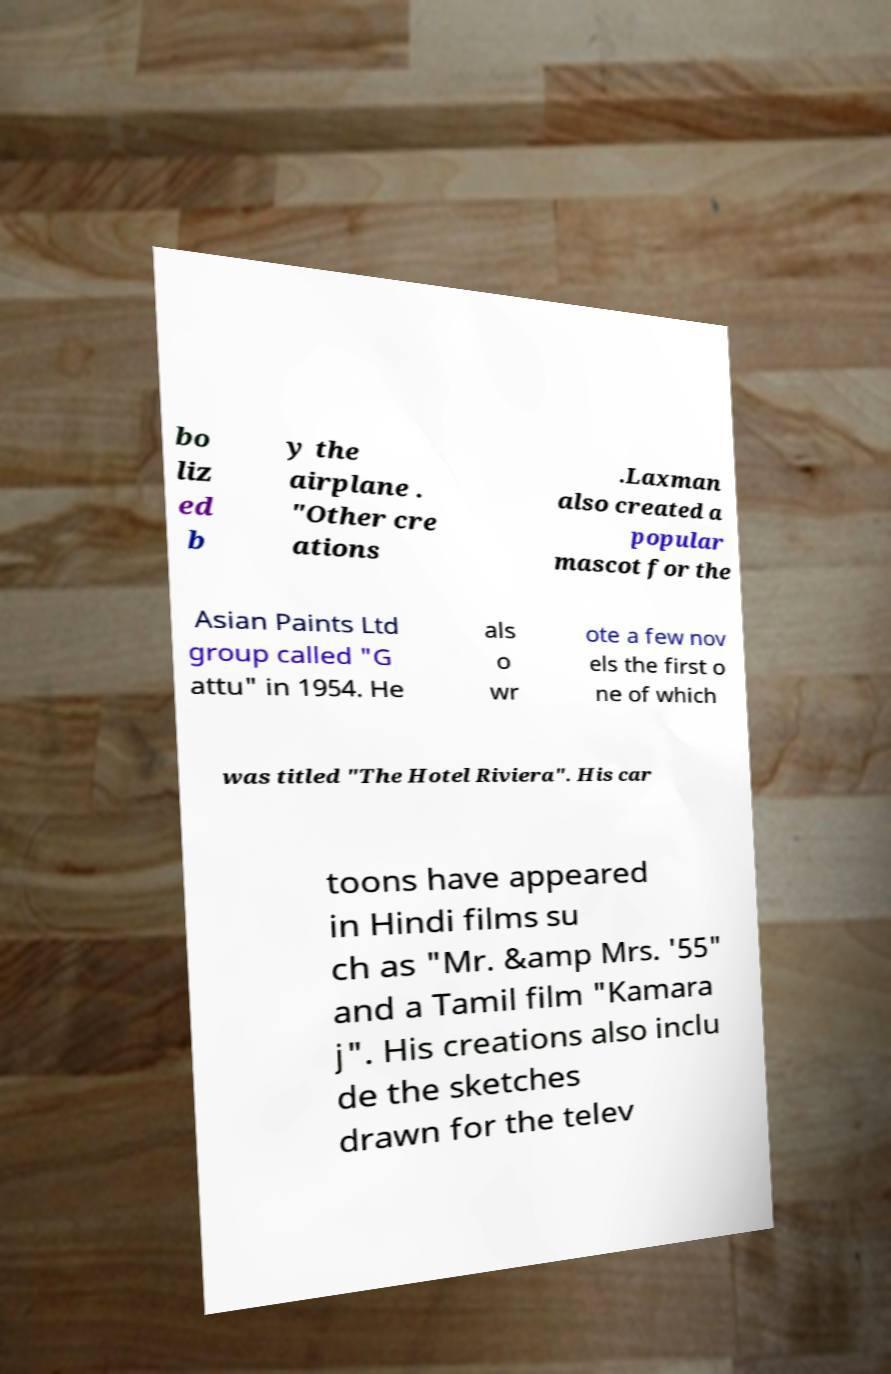Could you assist in decoding the text presented in this image and type it out clearly? bo liz ed b y the airplane . "Other cre ations .Laxman also created a popular mascot for the Asian Paints Ltd group called "G attu" in 1954. He als o wr ote a few nov els the first o ne of which was titled "The Hotel Riviera". His car toons have appeared in Hindi films su ch as "Mr. &amp Mrs. '55" and a Tamil film "Kamara j". His creations also inclu de the sketches drawn for the telev 